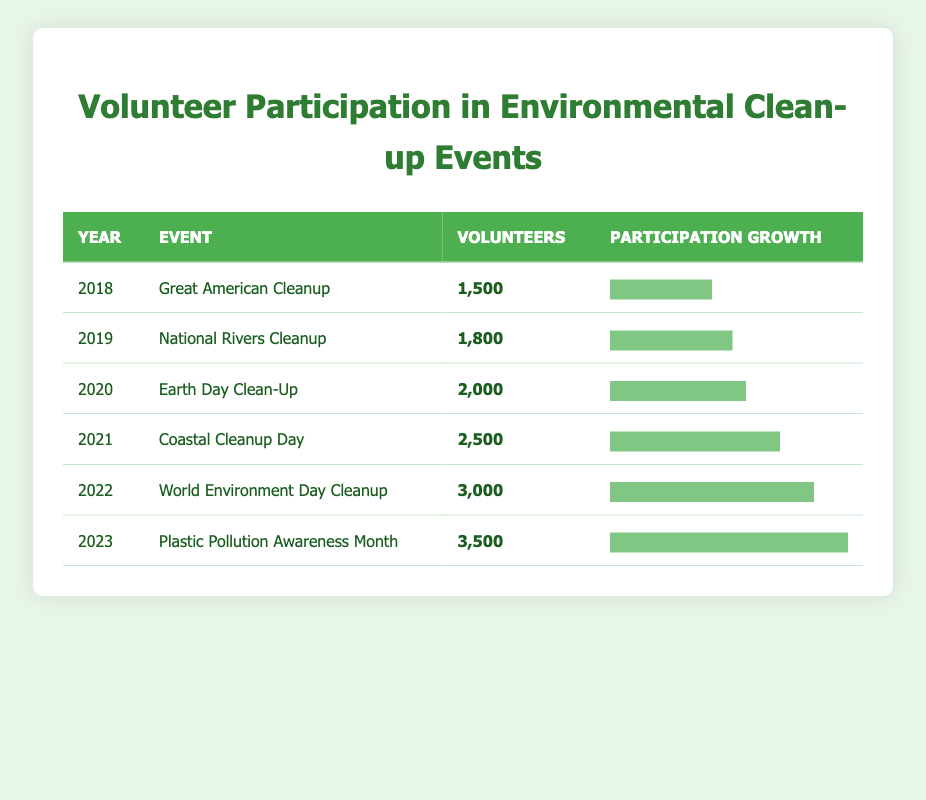What was the volunteer count for the Great American Cleanup in 2018? The table shows that in the year 2018, the event "Great American Cleanup" had a reported volunteer count of 1,500.
Answer: 1,500 What was the participation level for volunteers in 2022? In 2022, the "World Environment Day Cleanup" event had 3,000 volunteers recorded in the table.
Answer: 3,000 How many more volunteers participated in the Coastal Cleanup Day compared to the Great American Cleanup? The Coastal Cleanup Day in 2021 had 2,500 volunteers, while the Great American Cleanup in 2018 had 1,500 volunteers. The difference is 2,500 - 1,500 = 1,000 volunteers.
Answer: 1,000 What was the average number of volunteers for events from 2018 to 2023? Summing all volunteer counts from 2018 (1,500), 2019 (1,800), 2020 (2,000), 2021 (2,500), 2022 (3,000), and 2023 (3,500) gives us a total of 14,300 volunteers. There are 6 events, so the average is 14,300 / 6 = 2,383.33.
Answer: 2,383 Did the number of volunteers increase every year from 2018 to 2023? By examining the table, we can see that the number of volunteers rose steadily in each subsequent year from 2018 through 2023. Therefore, the answer is yes.
Answer: Yes What was the percentage growth in volunteer participation from 2019 to 2023? The volunteer count for 2019 was 1,800, and for 2023, it was 3,500. The growth is (3,500 - 1,800) / 1,800 * 100% = 94.44%.
Answer: 94.44% Which event had the highest volunteer participation? By analyzing the table, we see that the "Plastic Pollution Awareness Month" event in 2023 had the most volunteers at 3,500.
Answer: Plastic Pollution Awareness Month How many volunteers were there in the year with the lowest participation? The table reveals that in 2018, the Great American Cleanup had the lowest number of volunteers at 1,500 compared to other years listed.
Answer: 1,500 